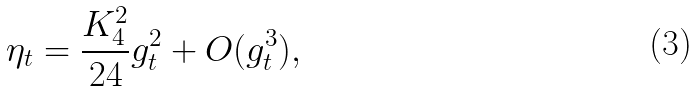<formula> <loc_0><loc_0><loc_500><loc_500>\eta _ { t } = \frac { K _ { 4 } ^ { 2 } } { 2 4 } g _ { t } ^ { 2 } + O ( g _ { t } ^ { 3 } ) ,</formula> 